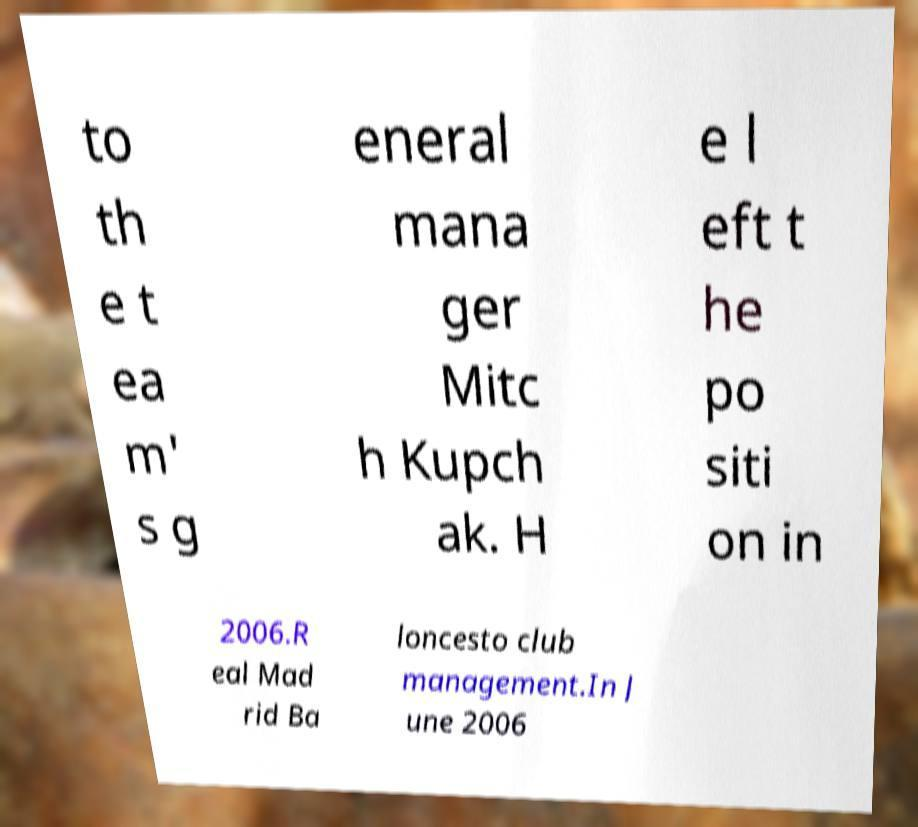Could you assist in decoding the text presented in this image and type it out clearly? to th e t ea m' s g eneral mana ger Mitc h Kupch ak. H e l eft t he po siti on in 2006.R eal Mad rid Ba loncesto club management.In J une 2006 